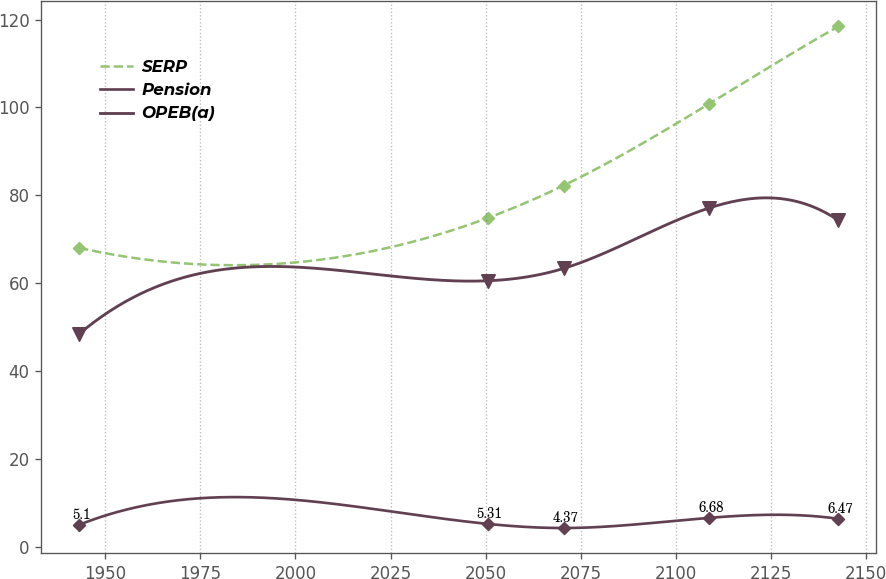<chart> <loc_0><loc_0><loc_500><loc_500><line_chart><ecel><fcel>SERP<fcel>Pension<fcel>OPEB(a)<nl><fcel>1943.18<fcel>68.08<fcel>5.1<fcel>48.52<nl><fcel>2050.52<fcel>74.86<fcel>5.31<fcel>60.59<nl><fcel>2070.47<fcel>82.25<fcel>4.37<fcel>63.39<nl><fcel>2108.71<fcel>100.82<fcel>6.68<fcel>77.13<nl><fcel>2142.68<fcel>118.42<fcel>6.47<fcel>74.34<nl></chart> 